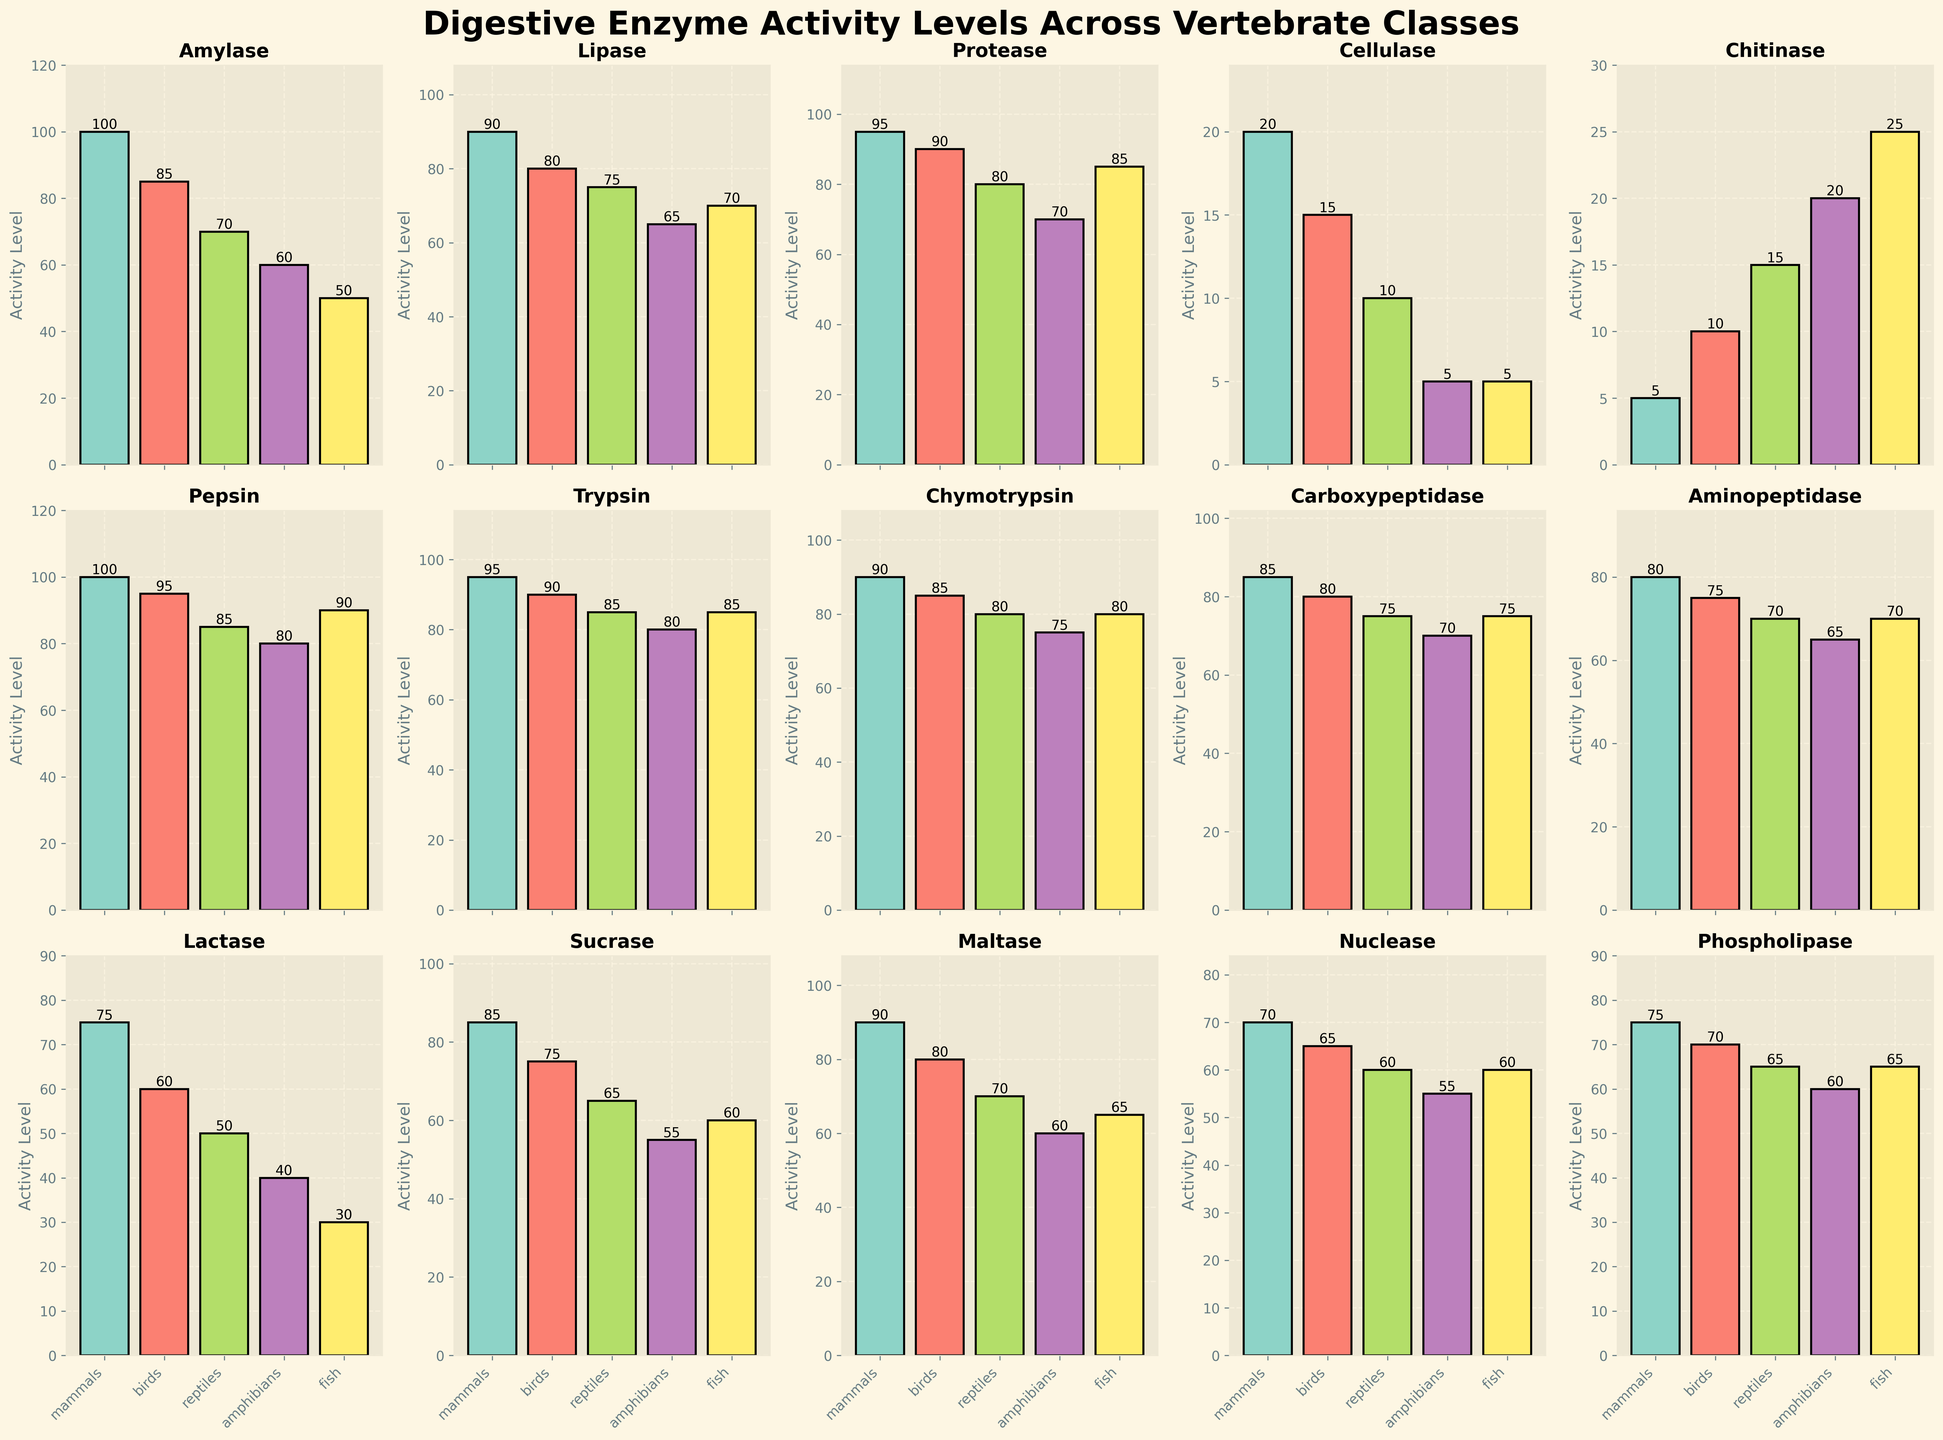Which vertebrate class has the highest pepsin activity level? Look at the "Pepsin" subplot and identify the bar with the greatest height. The tallest bar corresponds to mammals.
Answer: Mammals Compare the activity levels of trypsin in reptiles and fish; which one is higher? Locate the "Trypsin" subplot and compare the heights of the bars representing reptiles and fish. The bars are of equal height.
Answer: They are equal What is the difference in protease activity levels between mammals and amphibians? Find the "Protease" subplot and locate the bars for mammals and amphibians. The difference is calculated as 95 - 70.
Answer: 25 Which enzyme shows the smallest activity level across all vertebrate classes? Examine the subplots for the shortest bars across all enzymes. The enzyme with the smallest average height is Chitinase.
Answer: Chitinase Which enzyme has the most balanced activity levels across all vertebrate classes? Look for a subplot where the bars have nearly the same height across all classes. The subplot for Carboxypeptidase shows visually similar bar heights.
Answer: Carboxypeptidase What is the highest activity level of lactase and in which vertebrate class does it occur? Check the "Lactase" subplot to find the tallest bar, which corresponds to mammals. The height is 75.
Answer: 75 in Mammals Calculate the average activity level of phospholipase across all vertebrate classes. Find the "Phospholipase" subplot, sum the values (75 + 70 + 65 + 60 + 65 = 335), and divide by the number of classes (5). The average is 335 / 5.
Answer: 67 Which vertebrate class has the lowest activity level for protease? Look at the "Protease" subplot and identify the shortest bar, which belongs to amphibians with an activity level of 70.
Answer: Amphibians Compare the activity levels of maltase in birds and amphibians and determine the percentage difference. Find the "Maltase" subplot, locate the bars for birds (80) and amphibians (60), and calculate the percentage difference ((80 - 60) / 80 * 100).
Answer: 25% Which three enzymes have the highest activity levels in reptiles? Look at the enzyme subplots and identify the three tallest bars for reptiles. They are Protease (80), Pepsin (85), and Trypsin (85).
Answer: Protease, Pepsin, Trypsin 